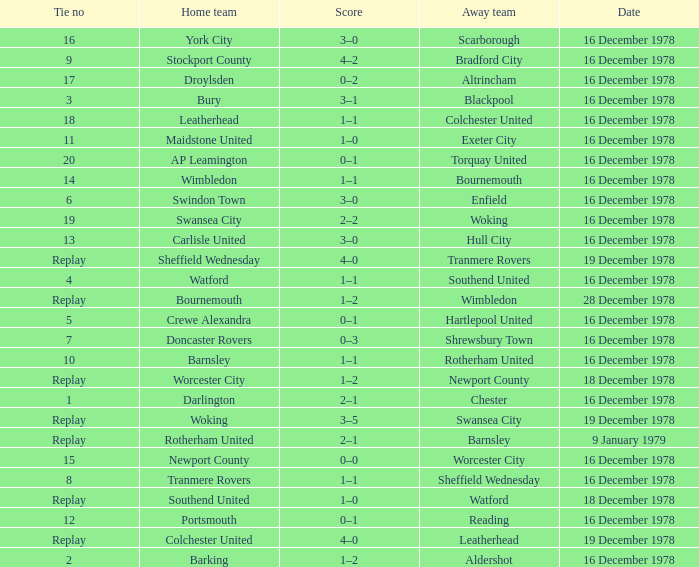What date had a tie no of replay, and an away team of watford? 18 December 1978. 